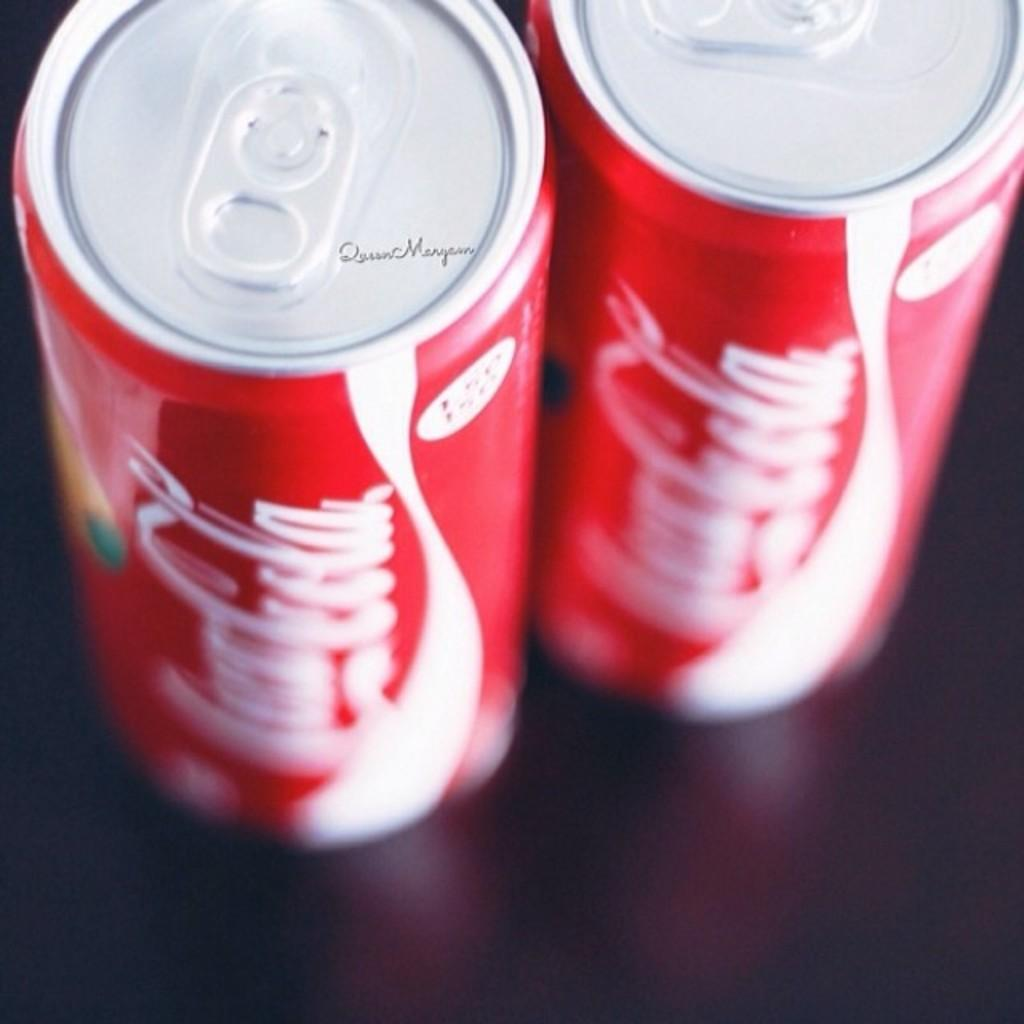Provide a one-sentence caption for the provided image. Two cans of Coca-Cola sit side by side. 